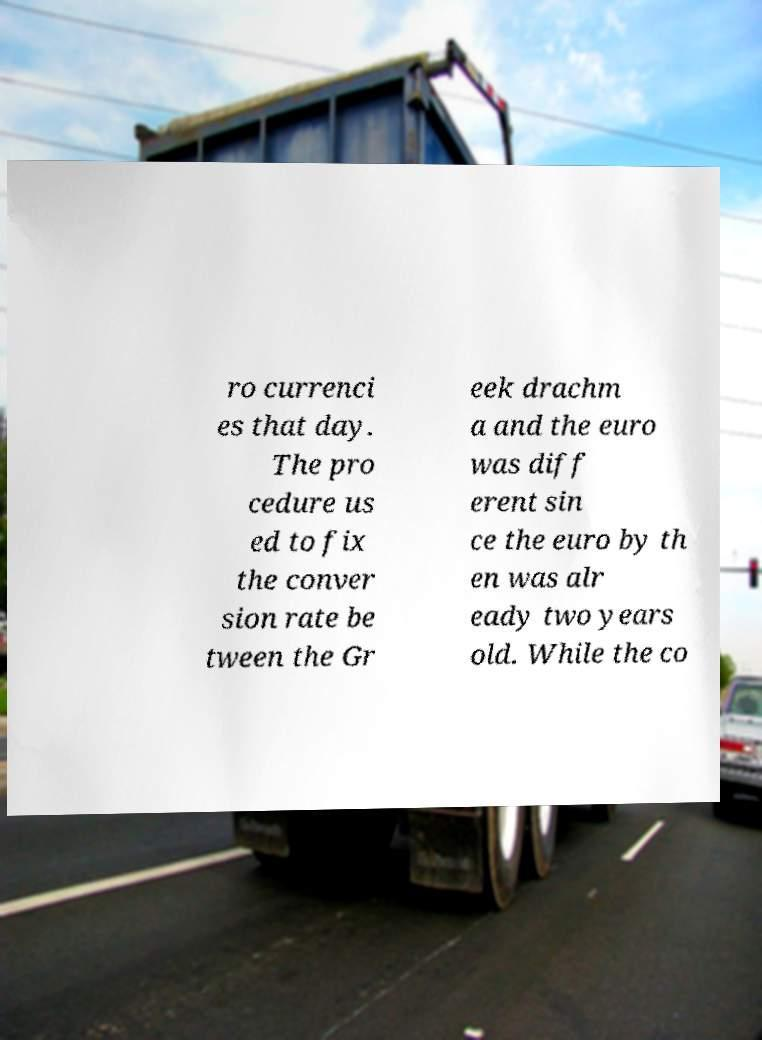For documentation purposes, I need the text within this image transcribed. Could you provide that? ro currenci es that day. The pro cedure us ed to fix the conver sion rate be tween the Gr eek drachm a and the euro was diff erent sin ce the euro by th en was alr eady two years old. While the co 